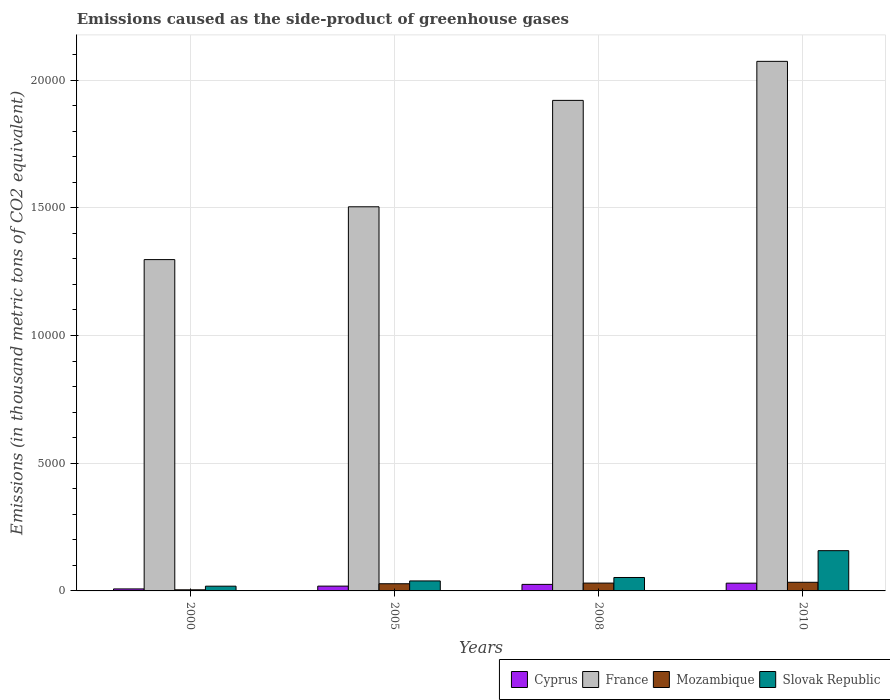How many different coloured bars are there?
Your response must be concise. 4. How many groups of bars are there?
Ensure brevity in your answer.  4. Are the number of bars per tick equal to the number of legend labels?
Your response must be concise. Yes. Are the number of bars on each tick of the X-axis equal?
Keep it short and to the point. Yes. How many bars are there on the 1st tick from the left?
Ensure brevity in your answer.  4. In how many cases, is the number of bars for a given year not equal to the number of legend labels?
Your answer should be compact. 0. What is the emissions caused as the side-product of greenhouse gases in Cyprus in 2010?
Your answer should be compact. 304. Across all years, what is the maximum emissions caused as the side-product of greenhouse gases in Slovak Republic?
Offer a terse response. 1576. Across all years, what is the minimum emissions caused as the side-product of greenhouse gases in France?
Provide a succinct answer. 1.30e+04. In which year was the emissions caused as the side-product of greenhouse gases in Cyprus minimum?
Keep it short and to the point. 2000. What is the total emissions caused as the side-product of greenhouse gases in Cyprus in the graph?
Provide a short and direct response. 826.8. What is the difference between the emissions caused as the side-product of greenhouse gases in Mozambique in 2000 and that in 2005?
Provide a short and direct response. -237.4. What is the difference between the emissions caused as the side-product of greenhouse gases in Mozambique in 2008 and the emissions caused as the side-product of greenhouse gases in Cyprus in 2005?
Make the answer very short. 118.5. What is the average emissions caused as the side-product of greenhouse gases in France per year?
Give a very brief answer. 1.70e+04. In the year 2005, what is the difference between the emissions caused as the side-product of greenhouse gases in Cyprus and emissions caused as the side-product of greenhouse gases in Mozambique?
Keep it short and to the point. -92.8. In how many years, is the emissions caused as the side-product of greenhouse gases in France greater than 6000 thousand metric tons?
Your response must be concise. 4. What is the ratio of the emissions caused as the side-product of greenhouse gases in France in 2005 to that in 2008?
Offer a very short reply. 0.78. Is the difference between the emissions caused as the side-product of greenhouse gases in Cyprus in 2000 and 2005 greater than the difference between the emissions caused as the side-product of greenhouse gases in Mozambique in 2000 and 2005?
Your answer should be very brief. Yes. What is the difference between the highest and the second highest emissions caused as the side-product of greenhouse gases in France?
Make the answer very short. 1528. What is the difference between the highest and the lowest emissions caused as the side-product of greenhouse gases in Mozambique?
Your answer should be very brief. 294.3. In how many years, is the emissions caused as the side-product of greenhouse gases in Mozambique greater than the average emissions caused as the side-product of greenhouse gases in Mozambique taken over all years?
Provide a succinct answer. 3. Is it the case that in every year, the sum of the emissions caused as the side-product of greenhouse gases in Mozambique and emissions caused as the side-product of greenhouse gases in France is greater than the sum of emissions caused as the side-product of greenhouse gases in Cyprus and emissions caused as the side-product of greenhouse gases in Slovak Republic?
Keep it short and to the point. Yes. What does the 4th bar from the left in 2005 represents?
Provide a short and direct response. Slovak Republic. Are all the bars in the graph horizontal?
Your answer should be compact. No. How many years are there in the graph?
Offer a terse response. 4. What is the difference between two consecutive major ticks on the Y-axis?
Keep it short and to the point. 5000. Are the values on the major ticks of Y-axis written in scientific E-notation?
Offer a very short reply. No. Does the graph contain grids?
Your answer should be compact. Yes. Where does the legend appear in the graph?
Make the answer very short. Bottom right. What is the title of the graph?
Give a very brief answer. Emissions caused as the side-product of greenhouse gases. What is the label or title of the Y-axis?
Provide a short and direct response. Emissions (in thousand metric tons of CO2 equivalent). What is the Emissions (in thousand metric tons of CO2 equivalent) in Cyprus in 2000?
Give a very brief answer. 78.4. What is the Emissions (in thousand metric tons of CO2 equivalent) in France in 2000?
Your response must be concise. 1.30e+04. What is the Emissions (in thousand metric tons of CO2 equivalent) in Mozambique in 2000?
Ensure brevity in your answer.  43.7. What is the Emissions (in thousand metric tons of CO2 equivalent) of Slovak Republic in 2000?
Keep it short and to the point. 185.6. What is the Emissions (in thousand metric tons of CO2 equivalent) in Cyprus in 2005?
Provide a succinct answer. 188.3. What is the Emissions (in thousand metric tons of CO2 equivalent) of France in 2005?
Give a very brief answer. 1.50e+04. What is the Emissions (in thousand metric tons of CO2 equivalent) in Mozambique in 2005?
Provide a short and direct response. 281.1. What is the Emissions (in thousand metric tons of CO2 equivalent) in Slovak Republic in 2005?
Keep it short and to the point. 391.3. What is the Emissions (in thousand metric tons of CO2 equivalent) in Cyprus in 2008?
Ensure brevity in your answer.  256.1. What is the Emissions (in thousand metric tons of CO2 equivalent) in France in 2008?
Keep it short and to the point. 1.92e+04. What is the Emissions (in thousand metric tons of CO2 equivalent) in Mozambique in 2008?
Provide a succinct answer. 306.8. What is the Emissions (in thousand metric tons of CO2 equivalent) of Slovak Republic in 2008?
Make the answer very short. 525.8. What is the Emissions (in thousand metric tons of CO2 equivalent) in Cyprus in 2010?
Provide a short and direct response. 304. What is the Emissions (in thousand metric tons of CO2 equivalent) in France in 2010?
Your response must be concise. 2.07e+04. What is the Emissions (in thousand metric tons of CO2 equivalent) of Mozambique in 2010?
Provide a short and direct response. 338. What is the Emissions (in thousand metric tons of CO2 equivalent) of Slovak Republic in 2010?
Give a very brief answer. 1576. Across all years, what is the maximum Emissions (in thousand metric tons of CO2 equivalent) of Cyprus?
Offer a terse response. 304. Across all years, what is the maximum Emissions (in thousand metric tons of CO2 equivalent) of France?
Your answer should be very brief. 2.07e+04. Across all years, what is the maximum Emissions (in thousand metric tons of CO2 equivalent) of Mozambique?
Keep it short and to the point. 338. Across all years, what is the maximum Emissions (in thousand metric tons of CO2 equivalent) of Slovak Republic?
Provide a succinct answer. 1576. Across all years, what is the minimum Emissions (in thousand metric tons of CO2 equivalent) in Cyprus?
Offer a very short reply. 78.4. Across all years, what is the minimum Emissions (in thousand metric tons of CO2 equivalent) of France?
Your response must be concise. 1.30e+04. Across all years, what is the minimum Emissions (in thousand metric tons of CO2 equivalent) of Mozambique?
Provide a succinct answer. 43.7. Across all years, what is the minimum Emissions (in thousand metric tons of CO2 equivalent) of Slovak Republic?
Your answer should be very brief. 185.6. What is the total Emissions (in thousand metric tons of CO2 equivalent) in Cyprus in the graph?
Your response must be concise. 826.8. What is the total Emissions (in thousand metric tons of CO2 equivalent) in France in the graph?
Offer a very short reply. 6.79e+04. What is the total Emissions (in thousand metric tons of CO2 equivalent) in Mozambique in the graph?
Your answer should be compact. 969.6. What is the total Emissions (in thousand metric tons of CO2 equivalent) of Slovak Republic in the graph?
Your answer should be compact. 2678.7. What is the difference between the Emissions (in thousand metric tons of CO2 equivalent) in Cyprus in 2000 and that in 2005?
Offer a very short reply. -109.9. What is the difference between the Emissions (in thousand metric tons of CO2 equivalent) of France in 2000 and that in 2005?
Your answer should be very brief. -2068. What is the difference between the Emissions (in thousand metric tons of CO2 equivalent) in Mozambique in 2000 and that in 2005?
Offer a very short reply. -237.4. What is the difference between the Emissions (in thousand metric tons of CO2 equivalent) in Slovak Republic in 2000 and that in 2005?
Your answer should be compact. -205.7. What is the difference between the Emissions (in thousand metric tons of CO2 equivalent) of Cyprus in 2000 and that in 2008?
Give a very brief answer. -177.7. What is the difference between the Emissions (in thousand metric tons of CO2 equivalent) of France in 2000 and that in 2008?
Give a very brief answer. -6233.8. What is the difference between the Emissions (in thousand metric tons of CO2 equivalent) of Mozambique in 2000 and that in 2008?
Your answer should be very brief. -263.1. What is the difference between the Emissions (in thousand metric tons of CO2 equivalent) of Slovak Republic in 2000 and that in 2008?
Your response must be concise. -340.2. What is the difference between the Emissions (in thousand metric tons of CO2 equivalent) in Cyprus in 2000 and that in 2010?
Keep it short and to the point. -225.6. What is the difference between the Emissions (in thousand metric tons of CO2 equivalent) in France in 2000 and that in 2010?
Offer a very short reply. -7761.8. What is the difference between the Emissions (in thousand metric tons of CO2 equivalent) of Mozambique in 2000 and that in 2010?
Offer a terse response. -294.3. What is the difference between the Emissions (in thousand metric tons of CO2 equivalent) of Slovak Republic in 2000 and that in 2010?
Keep it short and to the point. -1390.4. What is the difference between the Emissions (in thousand metric tons of CO2 equivalent) of Cyprus in 2005 and that in 2008?
Give a very brief answer. -67.8. What is the difference between the Emissions (in thousand metric tons of CO2 equivalent) in France in 2005 and that in 2008?
Offer a terse response. -4165.8. What is the difference between the Emissions (in thousand metric tons of CO2 equivalent) of Mozambique in 2005 and that in 2008?
Offer a very short reply. -25.7. What is the difference between the Emissions (in thousand metric tons of CO2 equivalent) of Slovak Republic in 2005 and that in 2008?
Make the answer very short. -134.5. What is the difference between the Emissions (in thousand metric tons of CO2 equivalent) in Cyprus in 2005 and that in 2010?
Offer a terse response. -115.7. What is the difference between the Emissions (in thousand metric tons of CO2 equivalent) in France in 2005 and that in 2010?
Provide a short and direct response. -5693.8. What is the difference between the Emissions (in thousand metric tons of CO2 equivalent) in Mozambique in 2005 and that in 2010?
Keep it short and to the point. -56.9. What is the difference between the Emissions (in thousand metric tons of CO2 equivalent) in Slovak Republic in 2005 and that in 2010?
Ensure brevity in your answer.  -1184.7. What is the difference between the Emissions (in thousand metric tons of CO2 equivalent) in Cyprus in 2008 and that in 2010?
Your answer should be compact. -47.9. What is the difference between the Emissions (in thousand metric tons of CO2 equivalent) in France in 2008 and that in 2010?
Ensure brevity in your answer.  -1528. What is the difference between the Emissions (in thousand metric tons of CO2 equivalent) of Mozambique in 2008 and that in 2010?
Offer a terse response. -31.2. What is the difference between the Emissions (in thousand metric tons of CO2 equivalent) of Slovak Republic in 2008 and that in 2010?
Your answer should be compact. -1050.2. What is the difference between the Emissions (in thousand metric tons of CO2 equivalent) of Cyprus in 2000 and the Emissions (in thousand metric tons of CO2 equivalent) of France in 2005?
Keep it short and to the point. -1.50e+04. What is the difference between the Emissions (in thousand metric tons of CO2 equivalent) of Cyprus in 2000 and the Emissions (in thousand metric tons of CO2 equivalent) of Mozambique in 2005?
Provide a short and direct response. -202.7. What is the difference between the Emissions (in thousand metric tons of CO2 equivalent) in Cyprus in 2000 and the Emissions (in thousand metric tons of CO2 equivalent) in Slovak Republic in 2005?
Provide a succinct answer. -312.9. What is the difference between the Emissions (in thousand metric tons of CO2 equivalent) of France in 2000 and the Emissions (in thousand metric tons of CO2 equivalent) of Mozambique in 2005?
Your answer should be compact. 1.27e+04. What is the difference between the Emissions (in thousand metric tons of CO2 equivalent) in France in 2000 and the Emissions (in thousand metric tons of CO2 equivalent) in Slovak Republic in 2005?
Offer a terse response. 1.26e+04. What is the difference between the Emissions (in thousand metric tons of CO2 equivalent) in Mozambique in 2000 and the Emissions (in thousand metric tons of CO2 equivalent) in Slovak Republic in 2005?
Provide a short and direct response. -347.6. What is the difference between the Emissions (in thousand metric tons of CO2 equivalent) of Cyprus in 2000 and the Emissions (in thousand metric tons of CO2 equivalent) of France in 2008?
Provide a succinct answer. -1.91e+04. What is the difference between the Emissions (in thousand metric tons of CO2 equivalent) of Cyprus in 2000 and the Emissions (in thousand metric tons of CO2 equivalent) of Mozambique in 2008?
Ensure brevity in your answer.  -228.4. What is the difference between the Emissions (in thousand metric tons of CO2 equivalent) in Cyprus in 2000 and the Emissions (in thousand metric tons of CO2 equivalent) in Slovak Republic in 2008?
Your answer should be very brief. -447.4. What is the difference between the Emissions (in thousand metric tons of CO2 equivalent) of France in 2000 and the Emissions (in thousand metric tons of CO2 equivalent) of Mozambique in 2008?
Your response must be concise. 1.27e+04. What is the difference between the Emissions (in thousand metric tons of CO2 equivalent) of France in 2000 and the Emissions (in thousand metric tons of CO2 equivalent) of Slovak Republic in 2008?
Make the answer very short. 1.24e+04. What is the difference between the Emissions (in thousand metric tons of CO2 equivalent) in Mozambique in 2000 and the Emissions (in thousand metric tons of CO2 equivalent) in Slovak Republic in 2008?
Your answer should be compact. -482.1. What is the difference between the Emissions (in thousand metric tons of CO2 equivalent) in Cyprus in 2000 and the Emissions (in thousand metric tons of CO2 equivalent) in France in 2010?
Ensure brevity in your answer.  -2.07e+04. What is the difference between the Emissions (in thousand metric tons of CO2 equivalent) in Cyprus in 2000 and the Emissions (in thousand metric tons of CO2 equivalent) in Mozambique in 2010?
Your answer should be very brief. -259.6. What is the difference between the Emissions (in thousand metric tons of CO2 equivalent) in Cyprus in 2000 and the Emissions (in thousand metric tons of CO2 equivalent) in Slovak Republic in 2010?
Your answer should be very brief. -1497.6. What is the difference between the Emissions (in thousand metric tons of CO2 equivalent) of France in 2000 and the Emissions (in thousand metric tons of CO2 equivalent) of Mozambique in 2010?
Your answer should be compact. 1.26e+04. What is the difference between the Emissions (in thousand metric tons of CO2 equivalent) of France in 2000 and the Emissions (in thousand metric tons of CO2 equivalent) of Slovak Republic in 2010?
Provide a succinct answer. 1.14e+04. What is the difference between the Emissions (in thousand metric tons of CO2 equivalent) in Mozambique in 2000 and the Emissions (in thousand metric tons of CO2 equivalent) in Slovak Republic in 2010?
Offer a very short reply. -1532.3. What is the difference between the Emissions (in thousand metric tons of CO2 equivalent) in Cyprus in 2005 and the Emissions (in thousand metric tons of CO2 equivalent) in France in 2008?
Keep it short and to the point. -1.90e+04. What is the difference between the Emissions (in thousand metric tons of CO2 equivalent) in Cyprus in 2005 and the Emissions (in thousand metric tons of CO2 equivalent) in Mozambique in 2008?
Your response must be concise. -118.5. What is the difference between the Emissions (in thousand metric tons of CO2 equivalent) in Cyprus in 2005 and the Emissions (in thousand metric tons of CO2 equivalent) in Slovak Republic in 2008?
Offer a very short reply. -337.5. What is the difference between the Emissions (in thousand metric tons of CO2 equivalent) in France in 2005 and the Emissions (in thousand metric tons of CO2 equivalent) in Mozambique in 2008?
Make the answer very short. 1.47e+04. What is the difference between the Emissions (in thousand metric tons of CO2 equivalent) in France in 2005 and the Emissions (in thousand metric tons of CO2 equivalent) in Slovak Republic in 2008?
Offer a very short reply. 1.45e+04. What is the difference between the Emissions (in thousand metric tons of CO2 equivalent) in Mozambique in 2005 and the Emissions (in thousand metric tons of CO2 equivalent) in Slovak Republic in 2008?
Make the answer very short. -244.7. What is the difference between the Emissions (in thousand metric tons of CO2 equivalent) of Cyprus in 2005 and the Emissions (in thousand metric tons of CO2 equivalent) of France in 2010?
Your answer should be very brief. -2.05e+04. What is the difference between the Emissions (in thousand metric tons of CO2 equivalent) of Cyprus in 2005 and the Emissions (in thousand metric tons of CO2 equivalent) of Mozambique in 2010?
Your answer should be very brief. -149.7. What is the difference between the Emissions (in thousand metric tons of CO2 equivalent) of Cyprus in 2005 and the Emissions (in thousand metric tons of CO2 equivalent) of Slovak Republic in 2010?
Offer a terse response. -1387.7. What is the difference between the Emissions (in thousand metric tons of CO2 equivalent) in France in 2005 and the Emissions (in thousand metric tons of CO2 equivalent) in Mozambique in 2010?
Offer a very short reply. 1.47e+04. What is the difference between the Emissions (in thousand metric tons of CO2 equivalent) in France in 2005 and the Emissions (in thousand metric tons of CO2 equivalent) in Slovak Republic in 2010?
Your response must be concise. 1.35e+04. What is the difference between the Emissions (in thousand metric tons of CO2 equivalent) of Mozambique in 2005 and the Emissions (in thousand metric tons of CO2 equivalent) of Slovak Republic in 2010?
Give a very brief answer. -1294.9. What is the difference between the Emissions (in thousand metric tons of CO2 equivalent) in Cyprus in 2008 and the Emissions (in thousand metric tons of CO2 equivalent) in France in 2010?
Your answer should be very brief. -2.05e+04. What is the difference between the Emissions (in thousand metric tons of CO2 equivalent) in Cyprus in 2008 and the Emissions (in thousand metric tons of CO2 equivalent) in Mozambique in 2010?
Keep it short and to the point. -81.9. What is the difference between the Emissions (in thousand metric tons of CO2 equivalent) of Cyprus in 2008 and the Emissions (in thousand metric tons of CO2 equivalent) of Slovak Republic in 2010?
Your answer should be compact. -1319.9. What is the difference between the Emissions (in thousand metric tons of CO2 equivalent) of France in 2008 and the Emissions (in thousand metric tons of CO2 equivalent) of Mozambique in 2010?
Offer a very short reply. 1.89e+04. What is the difference between the Emissions (in thousand metric tons of CO2 equivalent) in France in 2008 and the Emissions (in thousand metric tons of CO2 equivalent) in Slovak Republic in 2010?
Give a very brief answer. 1.76e+04. What is the difference between the Emissions (in thousand metric tons of CO2 equivalent) of Mozambique in 2008 and the Emissions (in thousand metric tons of CO2 equivalent) of Slovak Republic in 2010?
Your response must be concise. -1269.2. What is the average Emissions (in thousand metric tons of CO2 equivalent) in Cyprus per year?
Your answer should be compact. 206.7. What is the average Emissions (in thousand metric tons of CO2 equivalent) in France per year?
Ensure brevity in your answer.  1.70e+04. What is the average Emissions (in thousand metric tons of CO2 equivalent) in Mozambique per year?
Offer a very short reply. 242.4. What is the average Emissions (in thousand metric tons of CO2 equivalent) of Slovak Republic per year?
Your answer should be compact. 669.67. In the year 2000, what is the difference between the Emissions (in thousand metric tons of CO2 equivalent) of Cyprus and Emissions (in thousand metric tons of CO2 equivalent) of France?
Your response must be concise. -1.29e+04. In the year 2000, what is the difference between the Emissions (in thousand metric tons of CO2 equivalent) in Cyprus and Emissions (in thousand metric tons of CO2 equivalent) in Mozambique?
Provide a short and direct response. 34.7. In the year 2000, what is the difference between the Emissions (in thousand metric tons of CO2 equivalent) of Cyprus and Emissions (in thousand metric tons of CO2 equivalent) of Slovak Republic?
Your answer should be very brief. -107.2. In the year 2000, what is the difference between the Emissions (in thousand metric tons of CO2 equivalent) of France and Emissions (in thousand metric tons of CO2 equivalent) of Mozambique?
Offer a very short reply. 1.29e+04. In the year 2000, what is the difference between the Emissions (in thousand metric tons of CO2 equivalent) in France and Emissions (in thousand metric tons of CO2 equivalent) in Slovak Republic?
Your response must be concise. 1.28e+04. In the year 2000, what is the difference between the Emissions (in thousand metric tons of CO2 equivalent) in Mozambique and Emissions (in thousand metric tons of CO2 equivalent) in Slovak Republic?
Your answer should be very brief. -141.9. In the year 2005, what is the difference between the Emissions (in thousand metric tons of CO2 equivalent) in Cyprus and Emissions (in thousand metric tons of CO2 equivalent) in France?
Give a very brief answer. -1.49e+04. In the year 2005, what is the difference between the Emissions (in thousand metric tons of CO2 equivalent) of Cyprus and Emissions (in thousand metric tons of CO2 equivalent) of Mozambique?
Ensure brevity in your answer.  -92.8. In the year 2005, what is the difference between the Emissions (in thousand metric tons of CO2 equivalent) of Cyprus and Emissions (in thousand metric tons of CO2 equivalent) of Slovak Republic?
Your answer should be compact. -203. In the year 2005, what is the difference between the Emissions (in thousand metric tons of CO2 equivalent) of France and Emissions (in thousand metric tons of CO2 equivalent) of Mozambique?
Offer a terse response. 1.48e+04. In the year 2005, what is the difference between the Emissions (in thousand metric tons of CO2 equivalent) in France and Emissions (in thousand metric tons of CO2 equivalent) in Slovak Republic?
Give a very brief answer. 1.46e+04. In the year 2005, what is the difference between the Emissions (in thousand metric tons of CO2 equivalent) of Mozambique and Emissions (in thousand metric tons of CO2 equivalent) of Slovak Republic?
Keep it short and to the point. -110.2. In the year 2008, what is the difference between the Emissions (in thousand metric tons of CO2 equivalent) in Cyprus and Emissions (in thousand metric tons of CO2 equivalent) in France?
Give a very brief answer. -1.89e+04. In the year 2008, what is the difference between the Emissions (in thousand metric tons of CO2 equivalent) of Cyprus and Emissions (in thousand metric tons of CO2 equivalent) of Mozambique?
Your response must be concise. -50.7. In the year 2008, what is the difference between the Emissions (in thousand metric tons of CO2 equivalent) of Cyprus and Emissions (in thousand metric tons of CO2 equivalent) of Slovak Republic?
Offer a very short reply. -269.7. In the year 2008, what is the difference between the Emissions (in thousand metric tons of CO2 equivalent) in France and Emissions (in thousand metric tons of CO2 equivalent) in Mozambique?
Your answer should be compact. 1.89e+04. In the year 2008, what is the difference between the Emissions (in thousand metric tons of CO2 equivalent) of France and Emissions (in thousand metric tons of CO2 equivalent) of Slovak Republic?
Offer a very short reply. 1.87e+04. In the year 2008, what is the difference between the Emissions (in thousand metric tons of CO2 equivalent) in Mozambique and Emissions (in thousand metric tons of CO2 equivalent) in Slovak Republic?
Your answer should be compact. -219. In the year 2010, what is the difference between the Emissions (in thousand metric tons of CO2 equivalent) in Cyprus and Emissions (in thousand metric tons of CO2 equivalent) in France?
Give a very brief answer. -2.04e+04. In the year 2010, what is the difference between the Emissions (in thousand metric tons of CO2 equivalent) of Cyprus and Emissions (in thousand metric tons of CO2 equivalent) of Mozambique?
Offer a terse response. -34. In the year 2010, what is the difference between the Emissions (in thousand metric tons of CO2 equivalent) of Cyprus and Emissions (in thousand metric tons of CO2 equivalent) of Slovak Republic?
Make the answer very short. -1272. In the year 2010, what is the difference between the Emissions (in thousand metric tons of CO2 equivalent) of France and Emissions (in thousand metric tons of CO2 equivalent) of Mozambique?
Provide a short and direct response. 2.04e+04. In the year 2010, what is the difference between the Emissions (in thousand metric tons of CO2 equivalent) of France and Emissions (in thousand metric tons of CO2 equivalent) of Slovak Republic?
Your answer should be very brief. 1.92e+04. In the year 2010, what is the difference between the Emissions (in thousand metric tons of CO2 equivalent) in Mozambique and Emissions (in thousand metric tons of CO2 equivalent) in Slovak Republic?
Your answer should be compact. -1238. What is the ratio of the Emissions (in thousand metric tons of CO2 equivalent) in Cyprus in 2000 to that in 2005?
Offer a terse response. 0.42. What is the ratio of the Emissions (in thousand metric tons of CO2 equivalent) of France in 2000 to that in 2005?
Your answer should be very brief. 0.86. What is the ratio of the Emissions (in thousand metric tons of CO2 equivalent) of Mozambique in 2000 to that in 2005?
Keep it short and to the point. 0.16. What is the ratio of the Emissions (in thousand metric tons of CO2 equivalent) in Slovak Republic in 2000 to that in 2005?
Your response must be concise. 0.47. What is the ratio of the Emissions (in thousand metric tons of CO2 equivalent) in Cyprus in 2000 to that in 2008?
Offer a terse response. 0.31. What is the ratio of the Emissions (in thousand metric tons of CO2 equivalent) of France in 2000 to that in 2008?
Keep it short and to the point. 0.68. What is the ratio of the Emissions (in thousand metric tons of CO2 equivalent) of Mozambique in 2000 to that in 2008?
Provide a short and direct response. 0.14. What is the ratio of the Emissions (in thousand metric tons of CO2 equivalent) of Slovak Republic in 2000 to that in 2008?
Offer a terse response. 0.35. What is the ratio of the Emissions (in thousand metric tons of CO2 equivalent) of Cyprus in 2000 to that in 2010?
Offer a terse response. 0.26. What is the ratio of the Emissions (in thousand metric tons of CO2 equivalent) in France in 2000 to that in 2010?
Offer a terse response. 0.63. What is the ratio of the Emissions (in thousand metric tons of CO2 equivalent) of Mozambique in 2000 to that in 2010?
Ensure brevity in your answer.  0.13. What is the ratio of the Emissions (in thousand metric tons of CO2 equivalent) in Slovak Republic in 2000 to that in 2010?
Your response must be concise. 0.12. What is the ratio of the Emissions (in thousand metric tons of CO2 equivalent) in Cyprus in 2005 to that in 2008?
Offer a terse response. 0.74. What is the ratio of the Emissions (in thousand metric tons of CO2 equivalent) in France in 2005 to that in 2008?
Offer a terse response. 0.78. What is the ratio of the Emissions (in thousand metric tons of CO2 equivalent) of Mozambique in 2005 to that in 2008?
Make the answer very short. 0.92. What is the ratio of the Emissions (in thousand metric tons of CO2 equivalent) of Slovak Republic in 2005 to that in 2008?
Your answer should be compact. 0.74. What is the ratio of the Emissions (in thousand metric tons of CO2 equivalent) in Cyprus in 2005 to that in 2010?
Make the answer very short. 0.62. What is the ratio of the Emissions (in thousand metric tons of CO2 equivalent) in France in 2005 to that in 2010?
Keep it short and to the point. 0.73. What is the ratio of the Emissions (in thousand metric tons of CO2 equivalent) in Mozambique in 2005 to that in 2010?
Provide a short and direct response. 0.83. What is the ratio of the Emissions (in thousand metric tons of CO2 equivalent) in Slovak Republic in 2005 to that in 2010?
Keep it short and to the point. 0.25. What is the ratio of the Emissions (in thousand metric tons of CO2 equivalent) in Cyprus in 2008 to that in 2010?
Your answer should be compact. 0.84. What is the ratio of the Emissions (in thousand metric tons of CO2 equivalent) of France in 2008 to that in 2010?
Make the answer very short. 0.93. What is the ratio of the Emissions (in thousand metric tons of CO2 equivalent) of Mozambique in 2008 to that in 2010?
Give a very brief answer. 0.91. What is the ratio of the Emissions (in thousand metric tons of CO2 equivalent) in Slovak Republic in 2008 to that in 2010?
Your answer should be very brief. 0.33. What is the difference between the highest and the second highest Emissions (in thousand metric tons of CO2 equivalent) of Cyprus?
Provide a short and direct response. 47.9. What is the difference between the highest and the second highest Emissions (in thousand metric tons of CO2 equivalent) of France?
Make the answer very short. 1528. What is the difference between the highest and the second highest Emissions (in thousand metric tons of CO2 equivalent) of Mozambique?
Your answer should be very brief. 31.2. What is the difference between the highest and the second highest Emissions (in thousand metric tons of CO2 equivalent) in Slovak Republic?
Provide a short and direct response. 1050.2. What is the difference between the highest and the lowest Emissions (in thousand metric tons of CO2 equivalent) of Cyprus?
Make the answer very short. 225.6. What is the difference between the highest and the lowest Emissions (in thousand metric tons of CO2 equivalent) in France?
Provide a succinct answer. 7761.8. What is the difference between the highest and the lowest Emissions (in thousand metric tons of CO2 equivalent) in Mozambique?
Your response must be concise. 294.3. What is the difference between the highest and the lowest Emissions (in thousand metric tons of CO2 equivalent) of Slovak Republic?
Keep it short and to the point. 1390.4. 